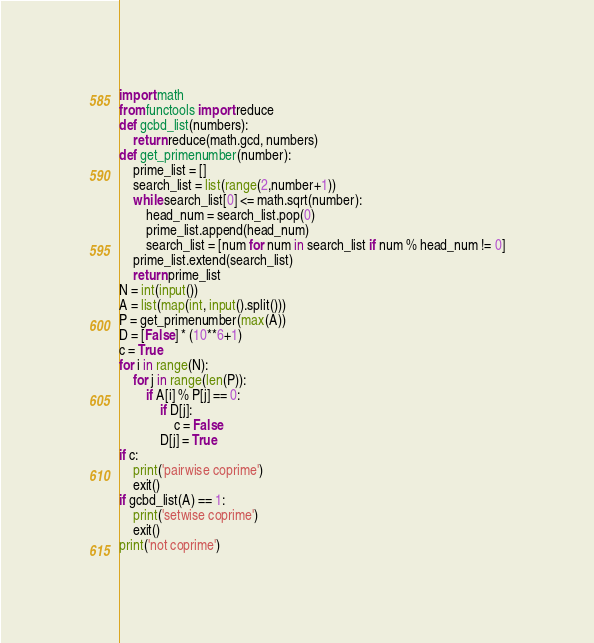<code> <loc_0><loc_0><loc_500><loc_500><_Python_>import math
from functools import reduce
def gcbd_list(numbers):
    return reduce(math.gcd, numbers)
def get_primenumber(number):
    prime_list = []
    search_list = list(range(2,number+1))
    while search_list[0] <= math.sqrt(number):
        head_num = search_list.pop(0)
        prime_list.append(head_num)
        search_list = [num for num in search_list if num % head_num != 0]
    prime_list.extend(search_list)
    return prime_list
N = int(input())
A = list(map(int, input().split()))
P = get_primenumber(max(A))
D = [False] * (10**6+1)
c = True
for i in range(N):
    for j in range(len(P)):
        if A[i] % P[j] == 0:
            if D[j]:
                c = False
            D[j] = True
if c:
    print('pairwise coprime')
    exit()
if gcbd_list(A) == 1:
    print('setwise coprime')
    exit()
print('not coprime')
</code> 